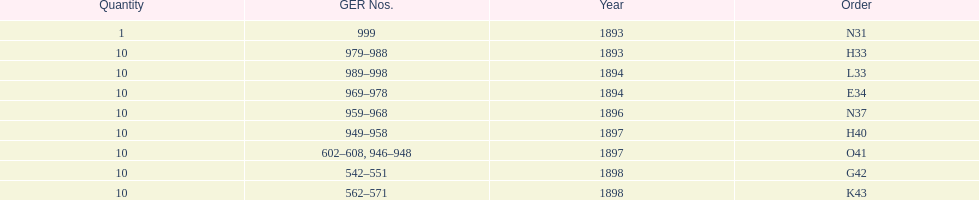Which entry appears first at the top of the table? N31. 